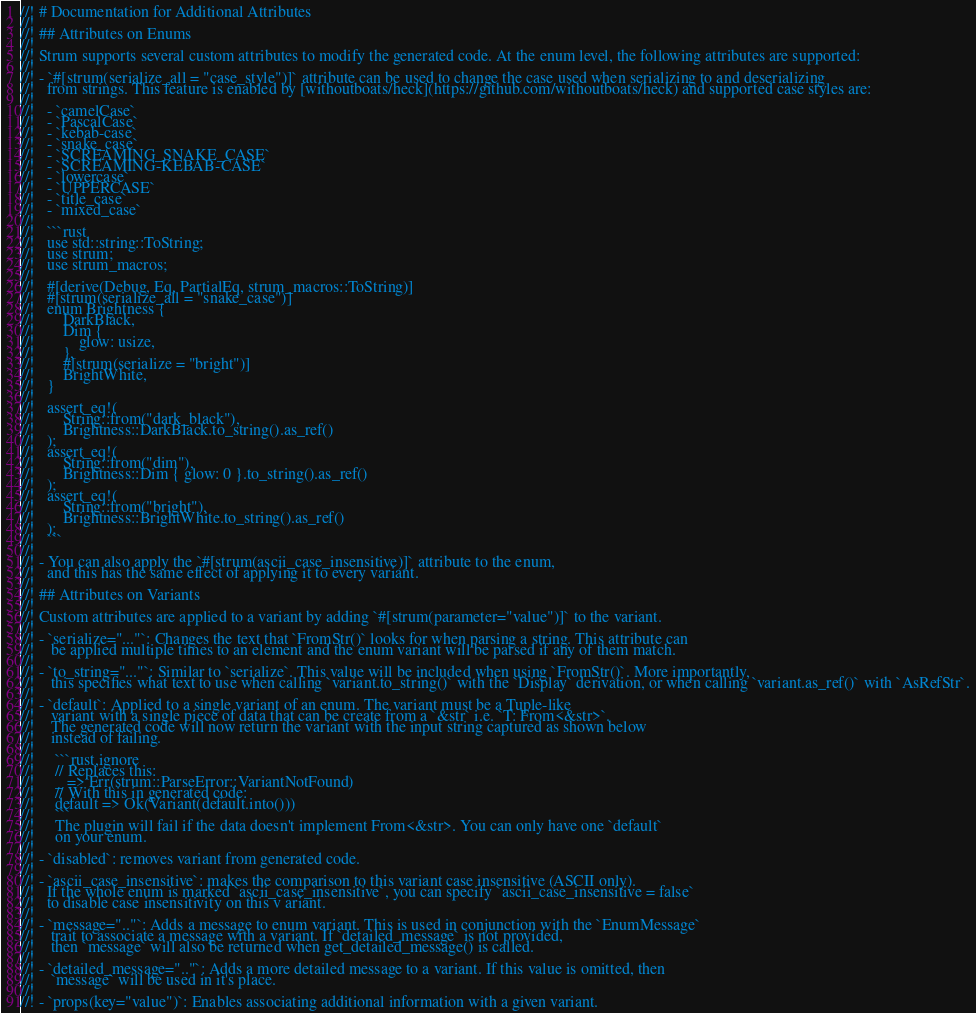<code> <loc_0><loc_0><loc_500><loc_500><_Rust_>//! # Documentation for Additional Attributes
//!
//! ## Attributes on Enums
//!
//! Strum supports several custom attributes to modify the generated code. At the enum level, the following attributes are supported:
//!
//! - `#[strum(serialize_all = "case_style")]` attribute can be used to change the case used when serializing to and deserializing
//!   from strings. This feature is enabled by [withoutboats/heck](https://github.com/withoutboats/heck) and supported case styles are:
//!
//!   - `camelCase`
//!   - `PascalCase`
//!   - `kebab-case`
//!   - `snake_case`
//!   - `SCREAMING_SNAKE_CASE`
//!   - `SCREAMING-KEBAB-CASE`
//!   - `lowercase`
//!   - `UPPERCASE`
//!   - `title_case`
//!   - `mixed_case`
//!
//!   ```rust
//!   use std::string::ToString;
//!   use strum;
//!   use strum_macros;
//!   
//!   #[derive(Debug, Eq, PartialEq, strum_macros::ToString)]
//!   #[strum(serialize_all = "snake_case")]
//!   enum Brightness {
//!       DarkBlack,
//!       Dim {
//!           glow: usize,
//!       },
//!       #[strum(serialize = "bright")]
//!       BrightWhite,
//!   }
//!   
//!   assert_eq!(
//!       String::from("dark_black"),
//!       Brightness::DarkBlack.to_string().as_ref()
//!   );
//!   assert_eq!(
//!       String::from("dim"),
//!       Brightness::Dim { glow: 0 }.to_string().as_ref()
//!   );
//!   assert_eq!(
//!       String::from("bright"),
//!       Brightness::BrightWhite.to_string().as_ref()
//!   );
//!   ```
//!
//! - You can also apply the `#[strum(ascii_case_insensitive)]` attribute to the enum,
//!   and this has the same effect of applying it to every variant.
//!
//! ## Attributes on Variants
//!
//! Custom attributes are applied to a variant by adding `#[strum(parameter="value")]` to the variant.
//!
//! - `serialize="..."`: Changes the text that `FromStr()` looks for when parsing a string. This attribute can
//!    be applied multiple times to an element and the enum variant will be parsed if any of them match.
//!
//! - `to_string="..."`: Similar to `serialize`. This value will be included when using `FromStr()`. More importantly,
//!    this specifies what text to use when calling `variant.to_string()` with the `Display` derivation, or when calling `variant.as_ref()` with `AsRefStr`.
//!
//! - `default`: Applied to a single variant of an enum. The variant must be a Tuple-like
//!    variant with a single piece of data that can be create from a `&str` i.e. `T: From<&str>`.
//!    The generated code will now return the variant with the input string captured as shown below
//!    instead of failing.
//!
//!     ```rust,ignore
//!     // Replaces this:
//!     _ => Err(strum::ParseError::VariantNotFound)
//!     // With this in generated code:
//!     default => Ok(Variant(default.into()))
//!     ```
//!     The plugin will fail if the data doesn't implement From<&str>. You can only have one `default`
//!     on your enum.
//!
//! - `disabled`: removes variant from generated code.
//!
//! - `ascii_case_insensitive`: makes the comparison to this variant case insensitive (ASCII only).
//!   If the whole enum is marked `ascii_case_insensitive`, you can specify `ascii_case_insensitive = false`
//!   to disable case insensitivity on this v ariant.
//!
//! - `message=".."`: Adds a message to enum variant. This is used in conjunction with the `EnumMessage`
//!    trait to associate a message with a variant. If `detailed_message` is not provided,
//!    then `message` will also be returned when get_detailed_message() is called.
//!
//! - `detailed_message=".."`: Adds a more detailed message to a variant. If this value is omitted, then
//!    `message` will be used in it's place.
//!
//! - `props(key="value")`: Enables associating additional information with a given variant.
</code> 